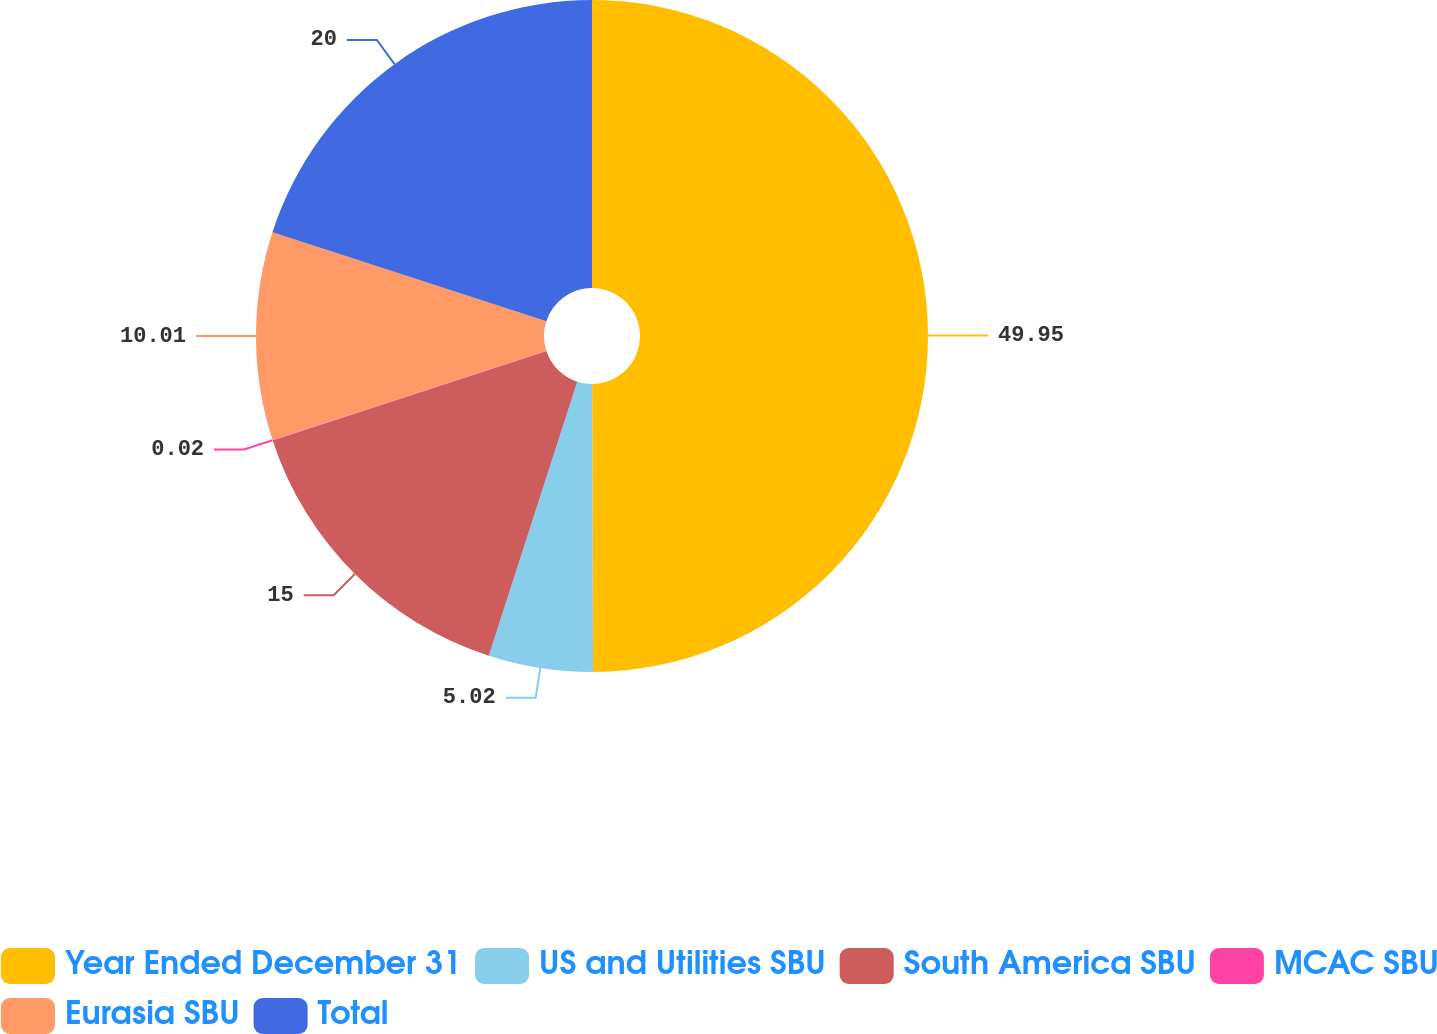Convert chart. <chart><loc_0><loc_0><loc_500><loc_500><pie_chart><fcel>Year Ended December 31<fcel>US and Utilities SBU<fcel>South America SBU<fcel>MCAC SBU<fcel>Eurasia SBU<fcel>Total<nl><fcel>49.95%<fcel>5.02%<fcel>15.0%<fcel>0.02%<fcel>10.01%<fcel>20.0%<nl></chart> 